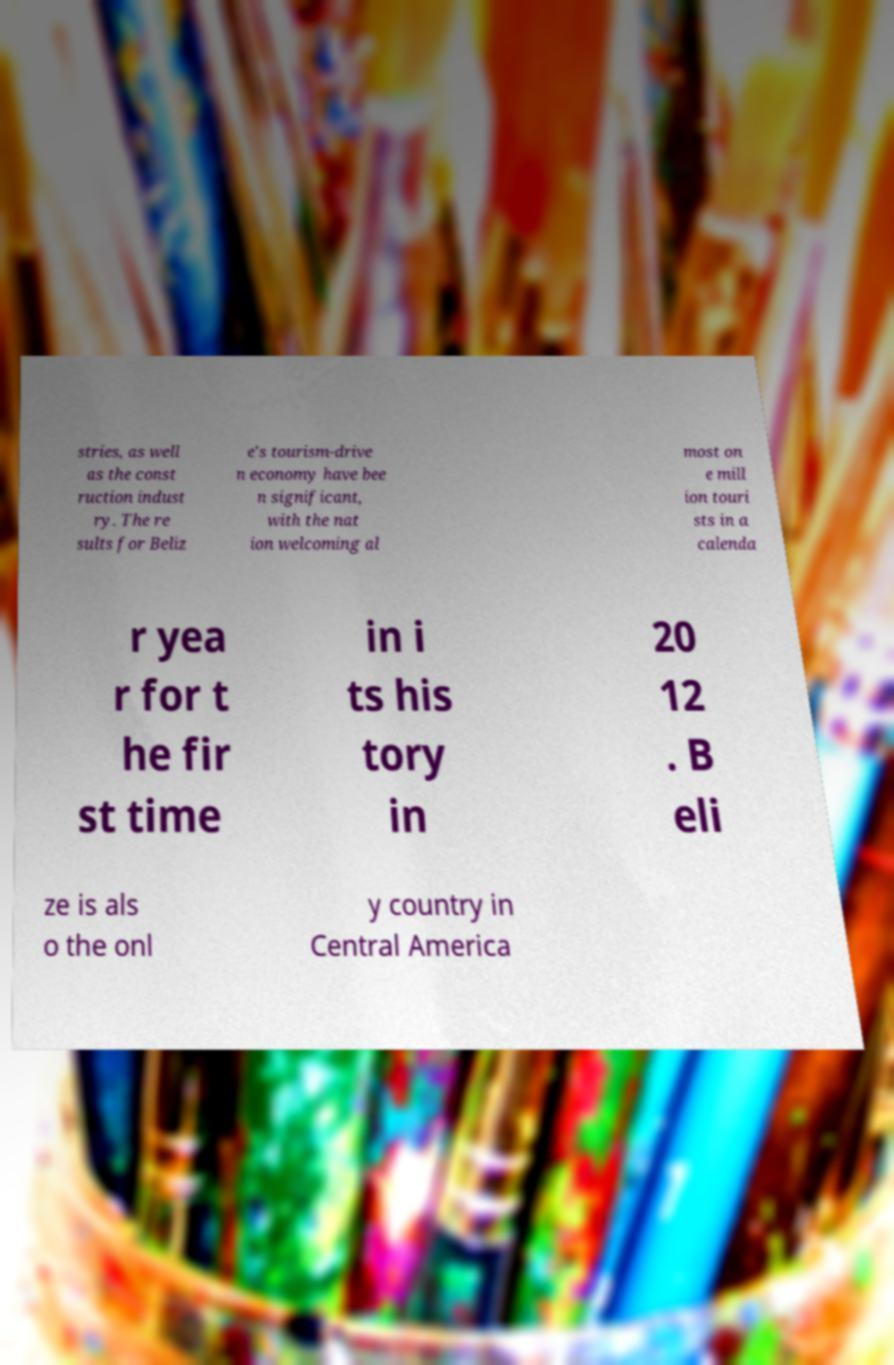Could you extract and type out the text from this image? stries, as well as the const ruction indust ry. The re sults for Beliz e's tourism-drive n economy have bee n significant, with the nat ion welcoming al most on e mill ion touri sts in a calenda r yea r for t he fir st time in i ts his tory in 20 12 . B eli ze is als o the onl y country in Central America 